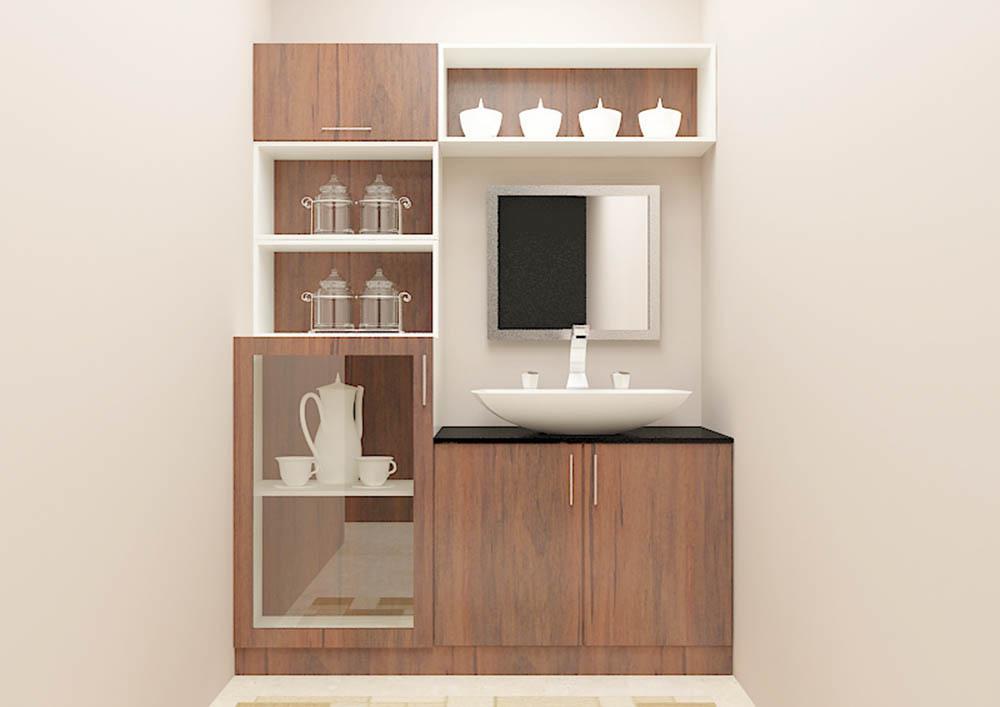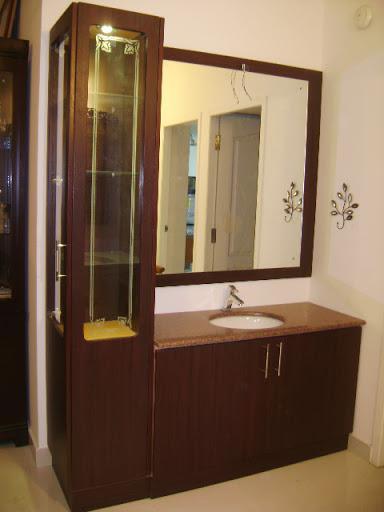The first image is the image on the left, the second image is the image on the right. For the images shown, is this caption "The right image shows glass-fronted black cabinets mounted on the wall above a counter with black cabinets that sits on the floor." true? Answer yes or no. No. The first image is the image on the left, the second image is the image on the right. Assess this claim about the two images: "Atleast one picture has black cabinets.". Correct or not? Answer yes or no. No. 